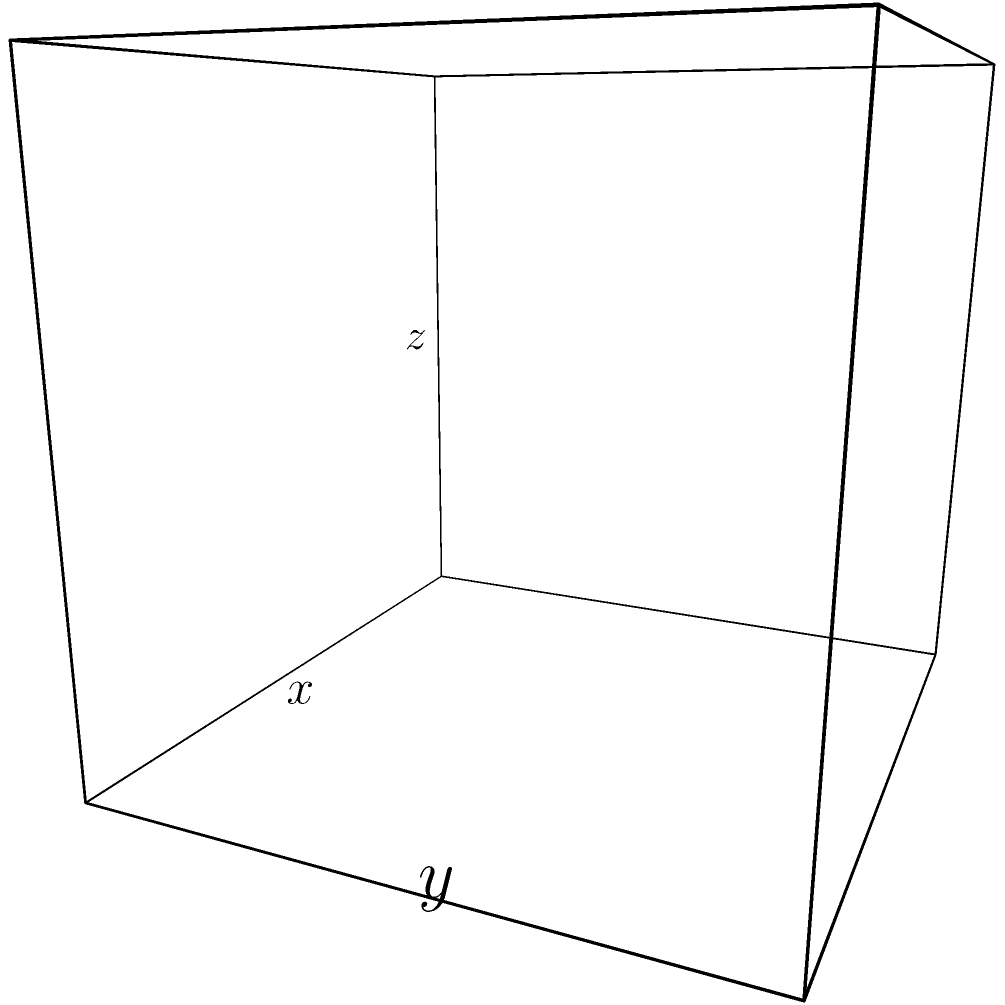Hey! Remember that cool project we talked about for the science fair? I've got this awesome idea for a rectangular box that maximizes volume. The box is made from a 12 cm by 8 cm piece of cardboard, and we need to cut out squares from each corner to fold it up. Can you help me figure out the size of the square we should cut out to get the biggest volume possible? Let's solve this together and blow everyone's minds at the fair! Alright, let's tackle this step-by-step:

1) Let's define our variables:
   $x$ = length of the square cut from each corner
   $l$ = length of the box
   $w$ = width of the box
   $h$ = height of the box

2) We can express $l$, $w$, and $h$ in terms of $x$:
   $l = 12 - 2x$
   $w = 8 - 2x$
   $h = x$

3) The volume of the box is given by $V = lwh$. Let's substitute our expressions:
   $V = (12-2x)(8-2x)(x)$

4) Expand this expression:
   $V = (96 - 24x - 16x + 4x^2)x$
   $V = 96x - 40x^2 + 4x^3$

5) To find the maximum volume, we need to find where $\frac{dV}{dx} = 0$:
   $\frac{dV}{dx} = 96 - 80x + 12x^2$

6) Set this equal to zero and solve:
   $96 - 80x + 12x^2 = 0$
   $12x^2 - 80x + 96 = 0$

7) This is a quadratic equation. We can solve it using the quadratic formula:
   $x = \frac{-b \pm \sqrt{b^2 - 4ac}}{2a}$

   Where $a = 12$, $b = -80$, and $c = 96$

8) Solving this:
   $x = \frac{80 \pm \sqrt{6400 - 4608}}{24} = \frac{80 \pm \sqrt{1792}}{24} = \frac{80 \pm 42.33}{24}$

9) This gives us two solutions: $x \approx 5.10$ or $x \approx 1.57$

10) The second solution ($x \approx 1.57$) is the one that maximizes the volume, as the first would result in negative dimensions for our box.

Therefore, we should cut squares with sides of approximately 1.57 cm from each corner to maximize the volume of the box.
Answer: $1.57$ cm 